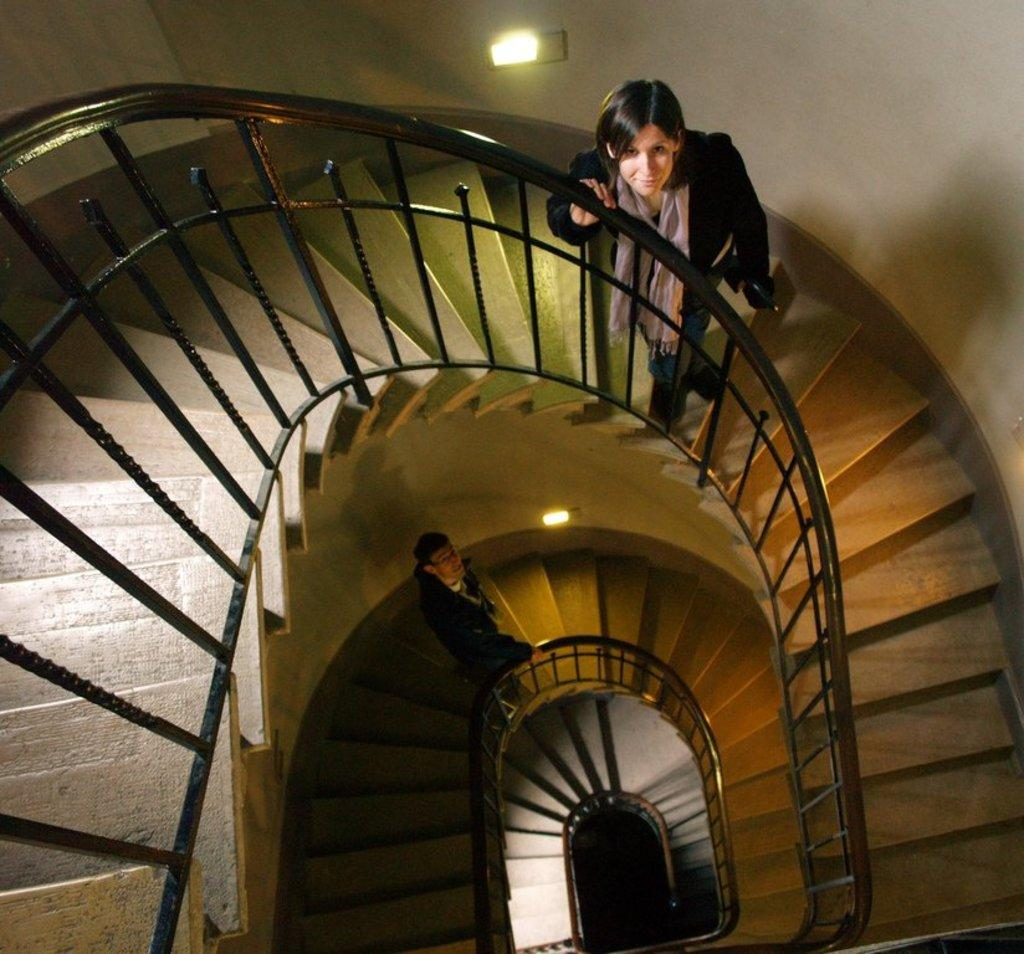How many people are present in the image? There are two people in the image, a man and a woman. What are the man and woman doing in the image? Both the man and woman are standing on stairs. What can be seen in the background of the image? There is a wall in the background of the image, and there are lights on the wall. What type of mouth can be seen on the woman's face in the image? There is no mouth visible on the woman's face in the image. 